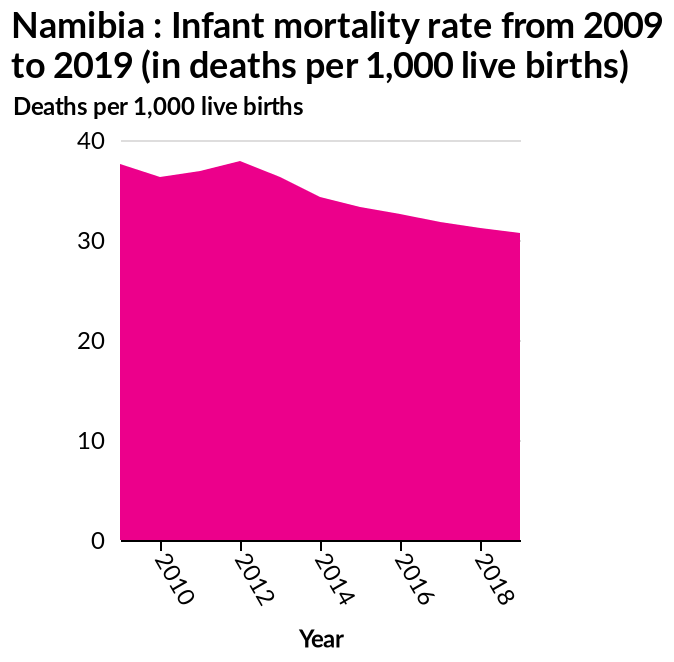<image>
What is the range of years covered in this area diagram?  The range of years covered in this area diagram is from 2009 to 2019. 